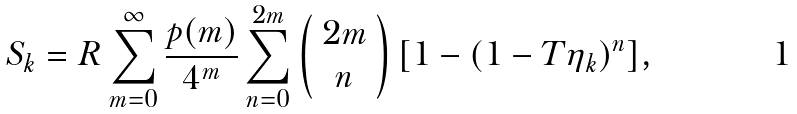<formula> <loc_0><loc_0><loc_500><loc_500>S _ { k } = R \sum _ { m = 0 } ^ { \infty } \frac { p ( m ) } { 4 ^ { m } } \sum _ { n = 0 } ^ { 2 m } \left ( \begin{array} { c } 2 m \\ n \end{array} \right ) [ 1 - ( 1 - T \eta _ { k } ) ^ { n } ] ,</formula> 